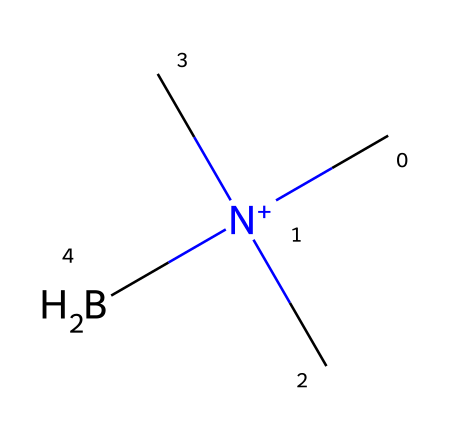What is the central atom in trimethylamine borane? In the provided structure, the central atom is identified as boron (B), which is typically at the center in borane compounds.
Answer: boron How many methyl groups are attached to the nitrogen in trimethylamine borane? The structure shows three carbon atoms (from the methyl groups) directly bonded to the nitrogen atom (N), indicating that there are three methyl groups.
Answer: three What type of charge is present on the nitrogen atom? The nitrogen atom in the compound has a positive charge, indicated by the notation [N+], which signifies it carries a formal positive charge.
Answer: positive What is the molecular formula of trimethylamine borane? By analyzing the structure, it can be deduced that the compound consists of three carbon atoms from the methyl groups, nine hydrogen atoms, one nitrogen atom, and one boron atom, resulting in the formula C3H12BN.
Answer: C3H12BN How does trimethylamine borane function in organic synthesis? Trimethylamine borane acts as a reducing agent, performing reductions of various functional groups, commonly in contexts where hydrogen transfer is required, which is a hallmark feature of its chemistry.
Answer: reducing agent What distinguishes trimethylamine borane from traditional boranes? Trimethylamine borane possesses a nitrogen atom that provides unique properties compared to traditional boranes, which generally lack such amine components, enhancing its reactivity in organic synthesis.
Answer: nitrogen component What is a notable property of trimethylamine borane due to its structure? The presence of multiple methyl groups and a positively charged nitrogen makes trimethylamine borane relatively stable and increases solubility in organic solvents, which is beneficial in synthetic applications.
Answer: stability and solubility 